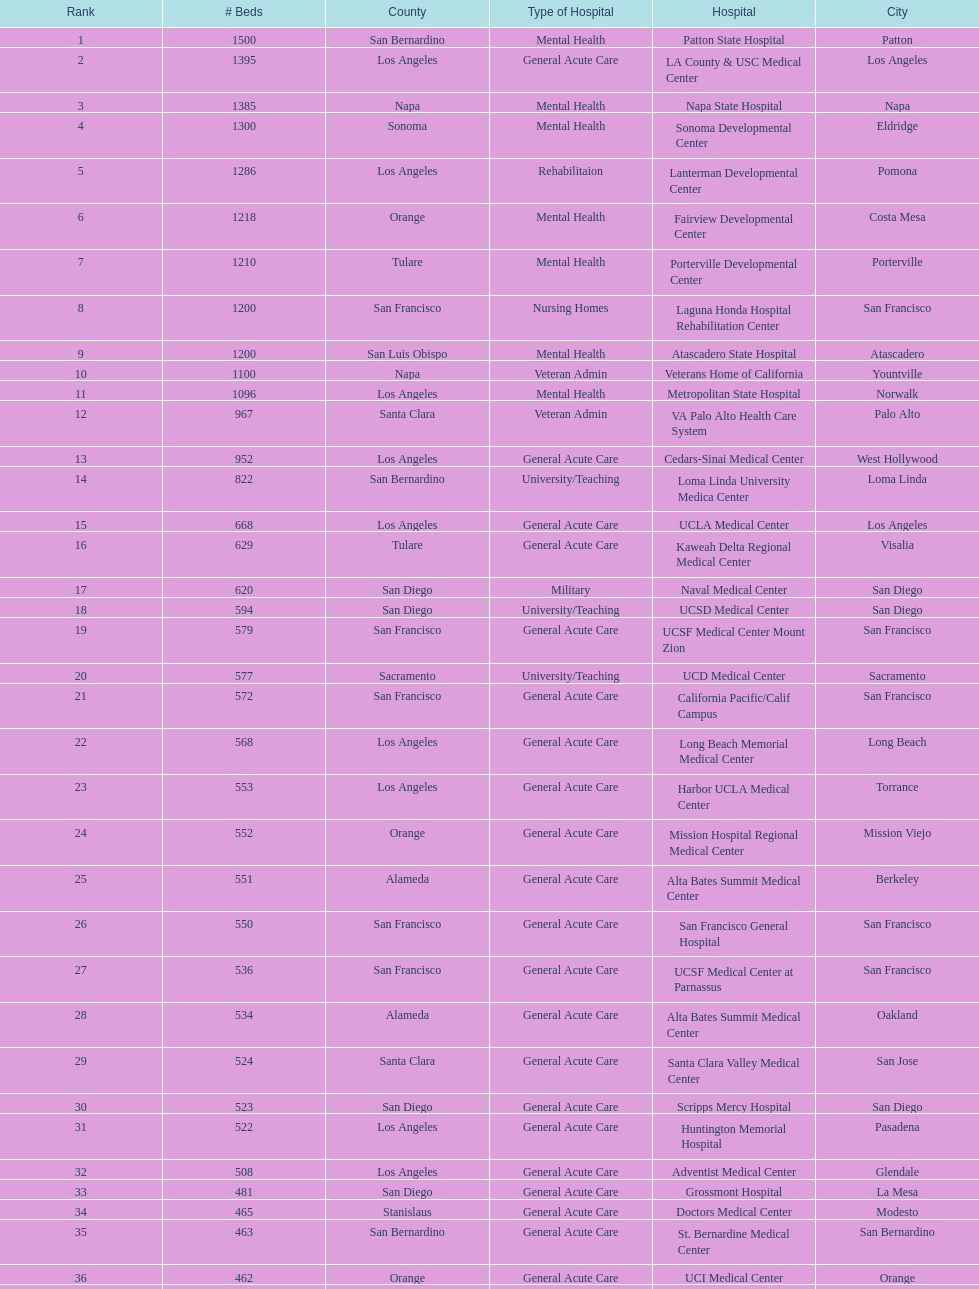Could you parse the entire table as a dict? {'header': ['Rank', '# Beds', 'County', 'Type of Hospital', 'Hospital', 'City'], 'rows': [['1', '1500', 'San Bernardino', 'Mental Health', 'Patton State Hospital', 'Patton'], ['2', '1395', 'Los Angeles', 'General Acute Care', 'LA County & USC Medical Center', 'Los Angeles'], ['3', '1385', 'Napa', 'Mental Health', 'Napa State Hospital', 'Napa'], ['4', '1300', 'Sonoma', 'Mental Health', 'Sonoma Developmental Center', 'Eldridge'], ['5', '1286', 'Los Angeles', 'Rehabilitaion', 'Lanterman Developmental Center', 'Pomona'], ['6', '1218', 'Orange', 'Mental Health', 'Fairview Developmental Center', 'Costa Mesa'], ['7', '1210', 'Tulare', 'Mental Health', 'Porterville Developmental Center', 'Porterville'], ['8', '1200', 'San Francisco', 'Nursing Homes', 'Laguna Honda Hospital Rehabilitation Center', 'San Francisco'], ['9', '1200', 'San Luis Obispo', 'Mental Health', 'Atascadero State Hospital', 'Atascadero'], ['10', '1100', 'Napa', 'Veteran Admin', 'Veterans Home of California', 'Yountville'], ['11', '1096', 'Los Angeles', 'Mental Health', 'Metropolitan State Hospital', 'Norwalk'], ['12', '967', 'Santa Clara', 'Veteran Admin', 'VA Palo Alto Health Care System', 'Palo Alto'], ['13', '952', 'Los Angeles', 'General Acute Care', 'Cedars-Sinai Medical Center', 'West Hollywood'], ['14', '822', 'San Bernardino', 'University/Teaching', 'Loma Linda University Medica Center', 'Loma Linda'], ['15', '668', 'Los Angeles', 'General Acute Care', 'UCLA Medical Center', 'Los Angeles'], ['16', '629', 'Tulare', 'General Acute Care', 'Kaweah Delta Regional Medical Center', 'Visalia'], ['17', '620', 'San Diego', 'Military', 'Naval Medical Center', 'San Diego'], ['18', '594', 'San Diego', 'University/Teaching', 'UCSD Medical Center', 'San Diego'], ['19', '579', 'San Francisco', 'General Acute Care', 'UCSF Medical Center Mount Zion', 'San Francisco'], ['20', '577', 'Sacramento', 'University/Teaching', 'UCD Medical Center', 'Sacramento'], ['21', '572', 'San Francisco', 'General Acute Care', 'California Pacific/Calif Campus', 'San Francisco'], ['22', '568', 'Los Angeles', 'General Acute Care', 'Long Beach Memorial Medical Center', 'Long Beach'], ['23', '553', 'Los Angeles', 'General Acute Care', 'Harbor UCLA Medical Center', 'Torrance'], ['24', '552', 'Orange', 'General Acute Care', 'Mission Hospital Regional Medical Center', 'Mission Viejo'], ['25', '551', 'Alameda', 'General Acute Care', 'Alta Bates Summit Medical Center', 'Berkeley'], ['26', '550', 'San Francisco', 'General Acute Care', 'San Francisco General Hospital', 'San Francisco'], ['27', '536', 'San Francisco', 'General Acute Care', 'UCSF Medical Center at Parnassus', 'San Francisco'], ['28', '534', 'Alameda', 'General Acute Care', 'Alta Bates Summit Medical Center', 'Oakland'], ['29', '524', 'Santa Clara', 'General Acute Care', 'Santa Clara Valley Medical Center', 'San Jose'], ['30', '523', 'San Diego', 'General Acute Care', 'Scripps Mercy Hospital', 'San Diego'], ['31', '522', 'Los Angeles', 'General Acute Care', 'Huntington Memorial Hospital', 'Pasadena'], ['32', '508', 'Los Angeles', 'General Acute Care', 'Adventist Medical Center', 'Glendale'], ['33', '481', 'San Diego', 'General Acute Care', 'Grossmont Hospital', 'La Mesa'], ['34', '465', 'Stanislaus', 'General Acute Care', 'Doctors Medical Center', 'Modesto'], ['35', '463', 'San Bernardino', 'General Acute Care', 'St. Bernardine Medical Center', 'San Bernardino'], ['36', '462', 'Orange', 'General Acute Care', 'UCI Medical Center', 'Orange'], ['37', '460', 'Santa Clara', 'General Acute Care', 'Stanford Medical Center', 'Stanford'], ['38', '457', 'Fresno', 'General Acute Care', 'Community Regional Medical Center', 'Fresno'], ['39', '455', 'Los Angeles', 'General Acute Care', 'Methodist Hospital', 'Arcadia'], ['40', '455', 'Los Angeles', 'General Acute Care', 'Providence St. Joseph Medical Center', 'Burbank'], ['41', '450', 'Orange', 'General Acute Care', 'Hoag Memorial Hospital', 'Newport Beach'], ['42', '450', 'Santa Clara', 'Mental Health', 'Agnews Developmental Center', 'San Jose'], ['43', '450', 'San Francisco', 'Nursing Homes', 'Jewish Home', 'San Francisco'], ['44', '448', 'Orange', 'General Acute Care', 'St. Joseph Hospital Orange', 'Orange'], ['45', '441', 'Los Angeles', 'General Acute Care', 'Presbyterian Intercommunity', 'Whittier'], ['46', '440', 'San Bernardino', 'General Acute Care', 'Kaiser Permanente Medical Center', 'Fontana'], ['47', '439', 'Los Angeles', 'General Acute Care', 'Kaiser Permanente Medical Center', 'Los Angeles'], ['48', '436', 'Los Angeles', 'General Acute Care', 'Pomona Valley Hospital Medical Center', 'Pomona'], ['49', '432', 'Sacramento', 'General Acute Care', 'Sutter General Medical Center', 'Sacramento'], ['50', '430', 'San Francisco', 'General Acute Care', 'St. Mary Medical Center', 'San Francisco'], ['50', '429', 'Santa Clara', 'General Acute Care', 'Good Samaritan Hospital', 'San Jose']]} What two hospitals holding consecutive rankings of 8 and 9 respectively, both provide 1200 hospital beds? Laguna Honda Hospital Rehabilitation Center, Atascadero State Hospital. 